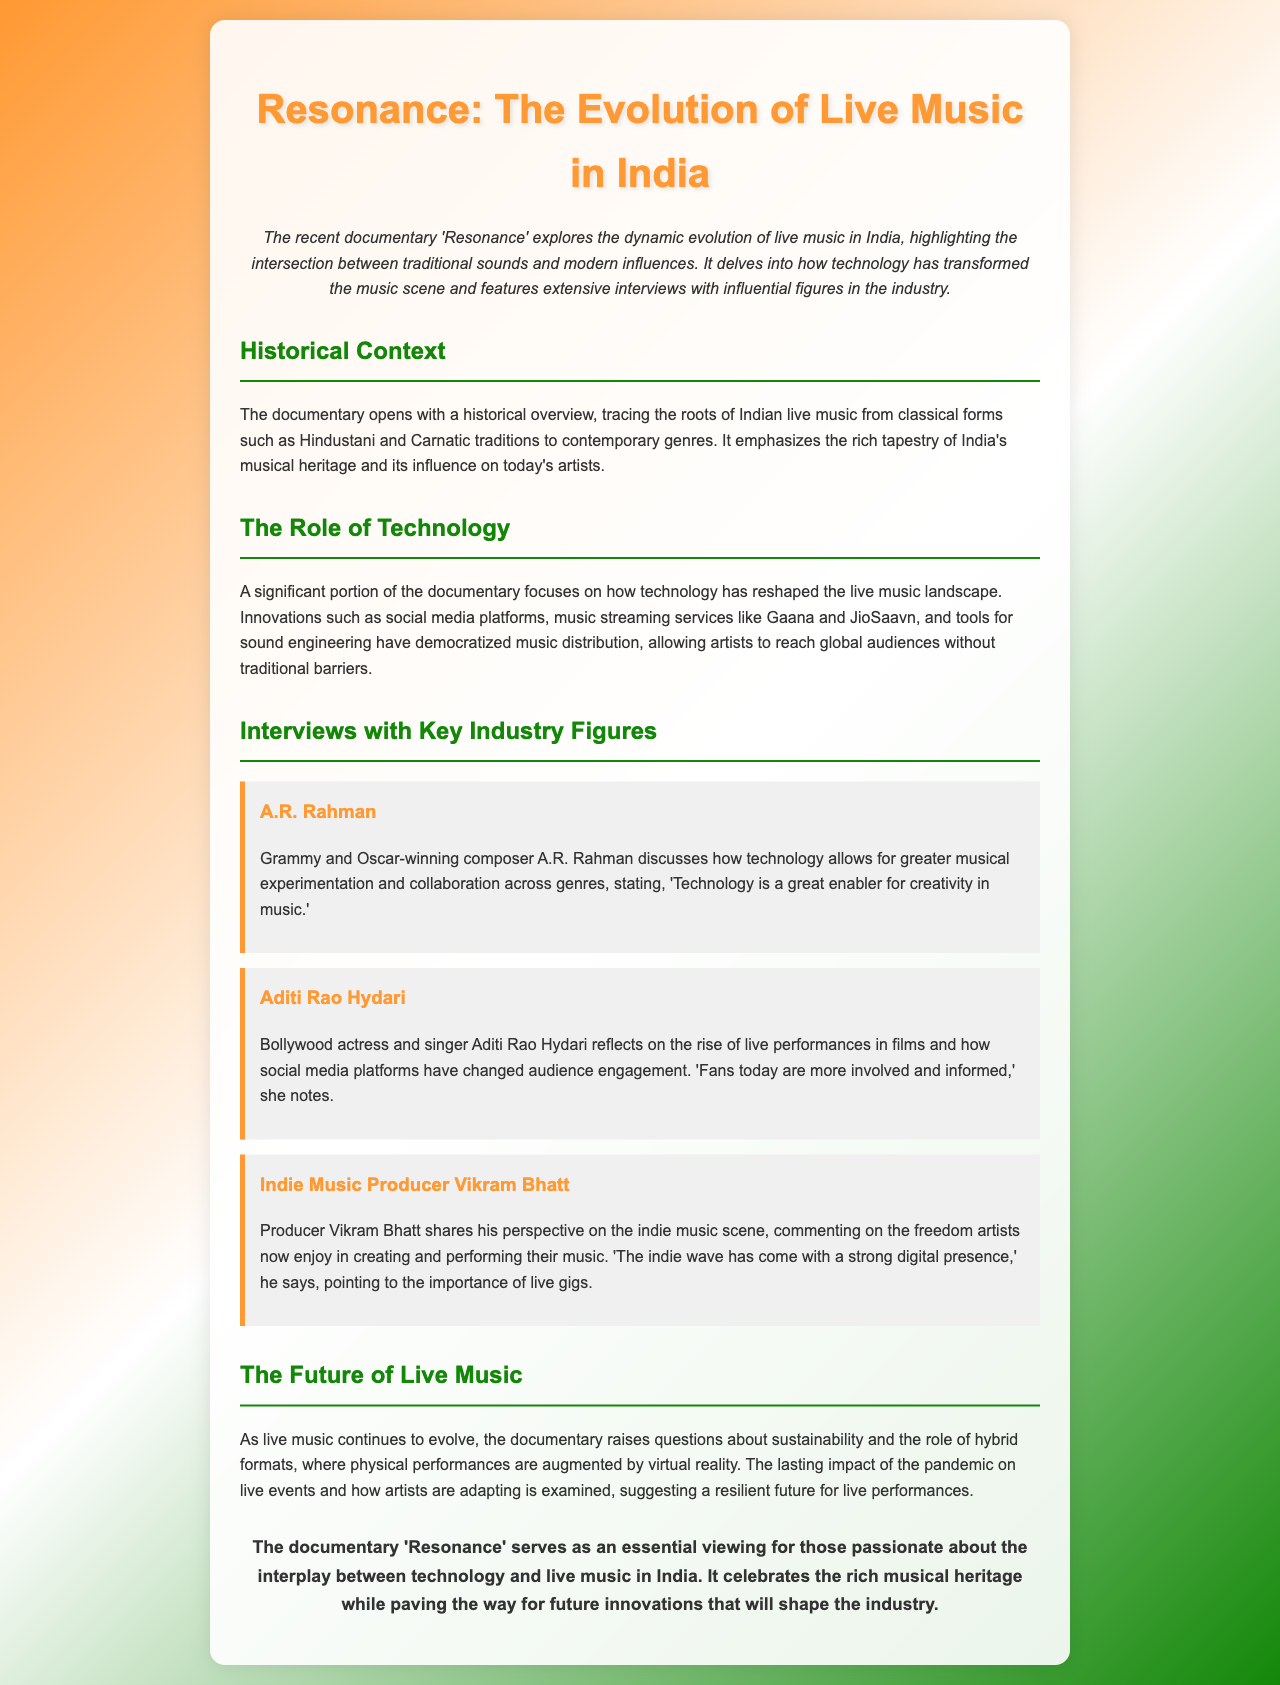What is the title of the documentary? The title of the documentary is mentioned in the introduction of the document.
Answer: Resonance Who directed the documentary? The document does not provide the name of the director.
Answer: Not specified Which two classical music traditions are referenced? The overview mentions two specific classical music traditions that are foundational to Indian music.
Answer: Hindustani and Carnatic What technological innovation has revolutionized music distribution? The document specifies a significant advancement that has changed how music is distributed.
Answer: Music streaming services Who is a prominent composer interviewed in the documentary? The names of key figures interviewed in the documentary are highlighted.
Answer: A.R. Rahman What insight does Aditi Rao Hydari provide? The actress shares her thoughts on how audience engagement has changed due to technology.
Answer: Fans today are more involved and informed What is the main theme discussed in the documentary? The documentary's primary subject is highlighted in the introduction.
Answer: Evolution of live music What future aspect does the documentary examine regarding live music? A element regarding the future challenges of live music is discussed in the conclusion.
Answer: Sustainability and hybrid formats 